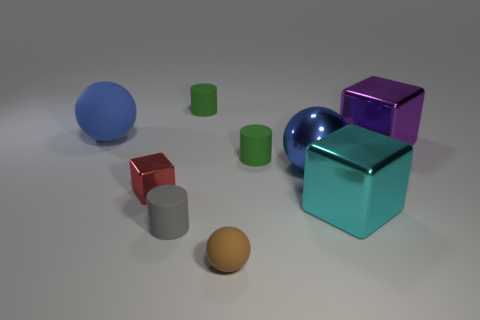What number of other things are the same color as the big metal ball?
Make the answer very short. 1. Is the size of the brown rubber thing the same as the gray matte object?
Give a very brief answer. Yes. What number of things are either gray matte cylinders or rubber balls behind the tiny red thing?
Keep it short and to the point. 2. Are there fewer blue matte things on the right side of the big metallic ball than gray matte cylinders that are left of the gray object?
Give a very brief answer. No. What number of other objects are there of the same material as the big purple block?
Give a very brief answer. 3. Does the rubber ball that is behind the tiny block have the same color as the big metal sphere?
Provide a short and direct response. Yes. Is there a matte object right of the green cylinder behind the large rubber object?
Make the answer very short. Yes. What material is the thing that is both in front of the purple metallic object and left of the small gray thing?
Your answer should be compact. Metal. There is a brown thing that is made of the same material as the gray cylinder; what shape is it?
Your answer should be compact. Sphere. Does the big blue ball that is to the right of the tiny red shiny object have the same material as the large cyan object?
Make the answer very short. Yes. 